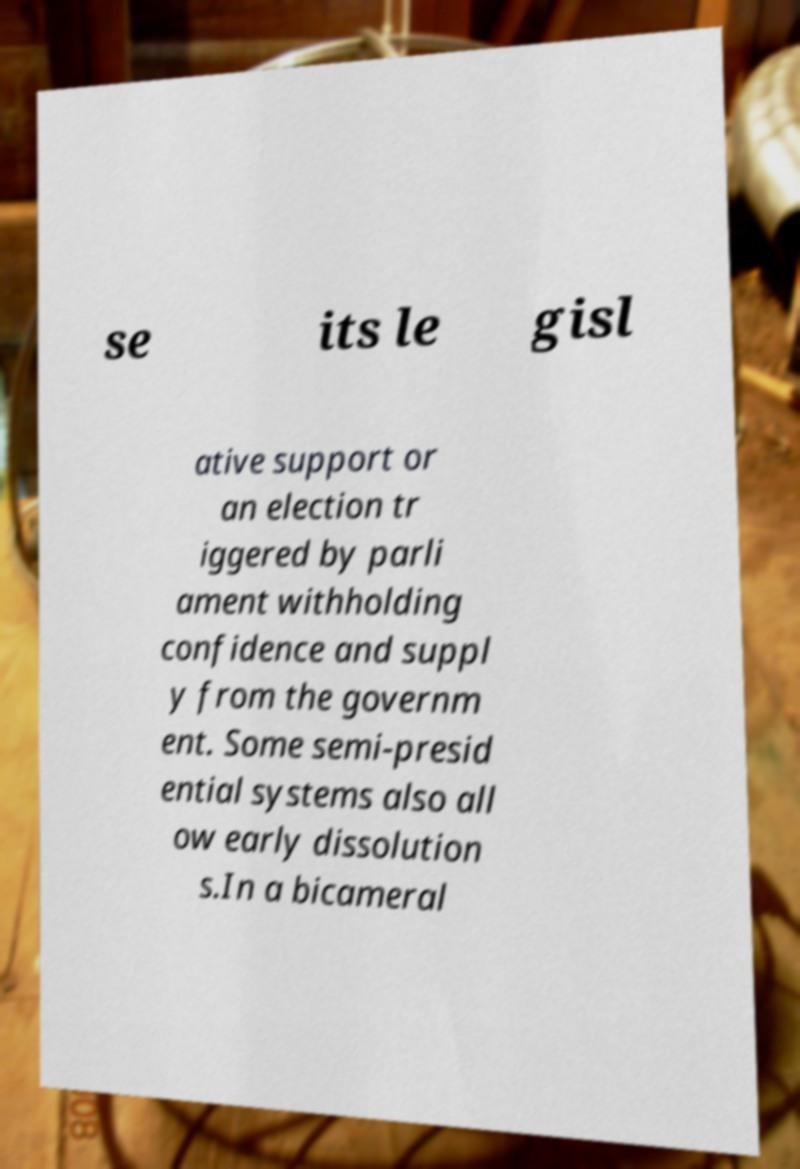There's text embedded in this image that I need extracted. Can you transcribe it verbatim? se its le gisl ative support or an election tr iggered by parli ament withholding confidence and suppl y from the governm ent. Some semi-presid ential systems also all ow early dissolution s.In a bicameral 